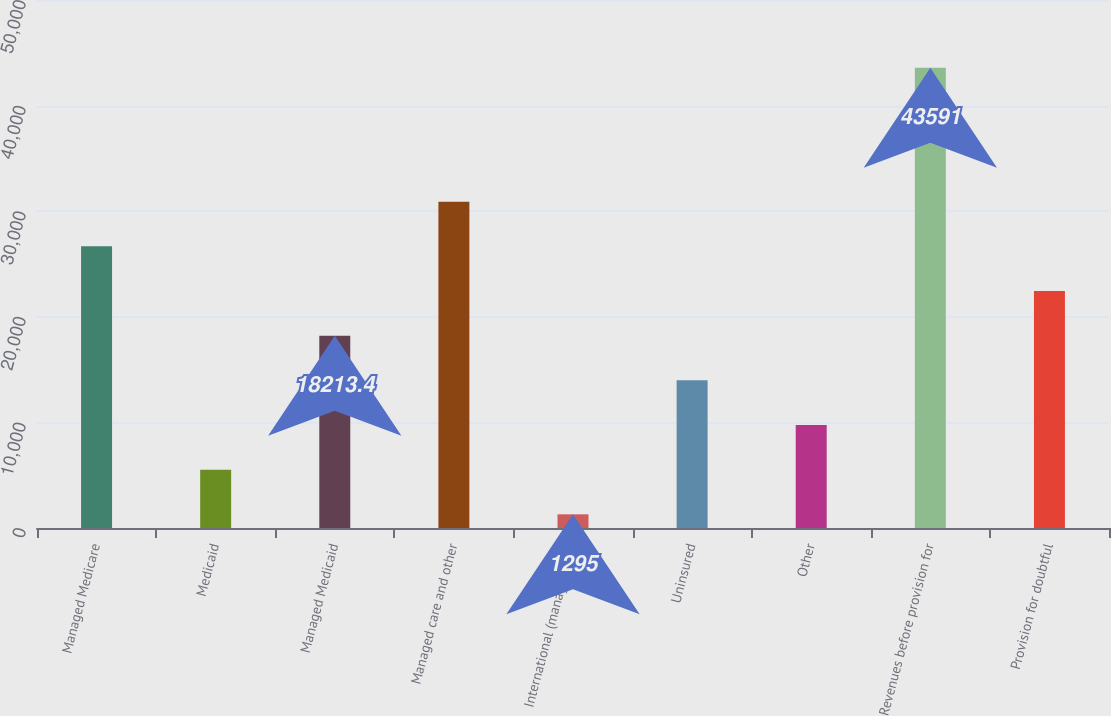<chart> <loc_0><loc_0><loc_500><loc_500><bar_chart><fcel>Managed Medicare<fcel>Medicaid<fcel>Managed Medicaid<fcel>Managed care and other<fcel>International (managed care<fcel>Uninsured<fcel>Other<fcel>Revenues before provision for<fcel>Provision for doubtful<nl><fcel>26672.6<fcel>5524.6<fcel>18213.4<fcel>30902.2<fcel>1295<fcel>13983.8<fcel>9754.2<fcel>43591<fcel>22443<nl></chart> 